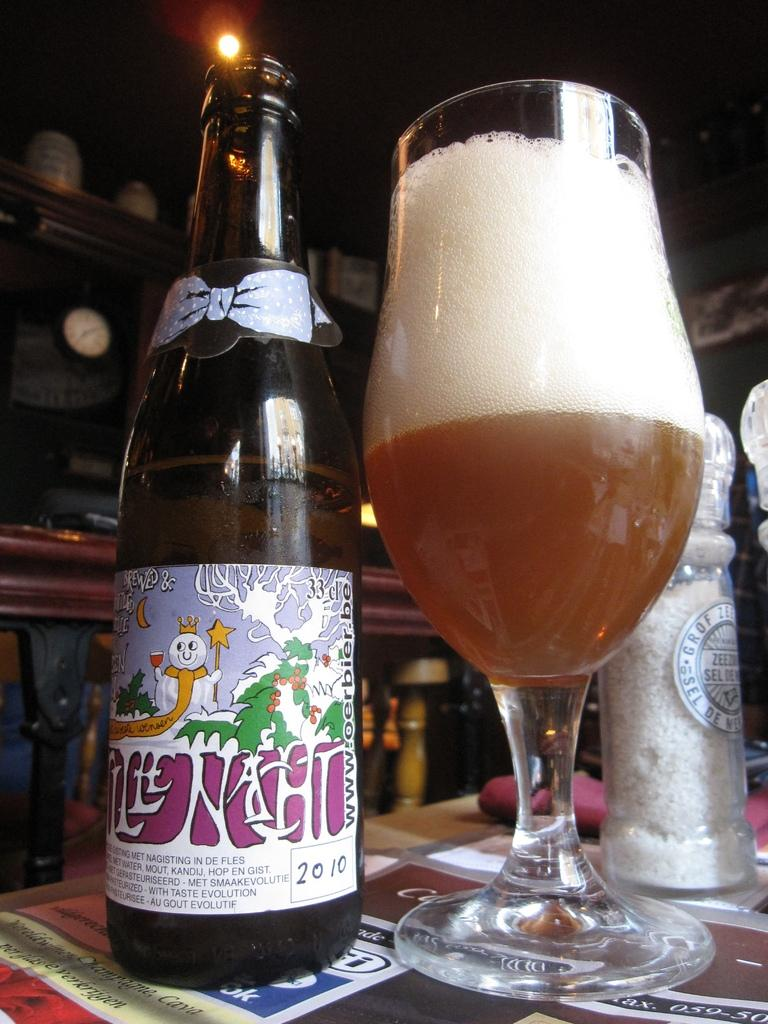Provide a one-sentence caption for the provided image. A bottle labeled with the year 2010 is on a table next to a glass. 